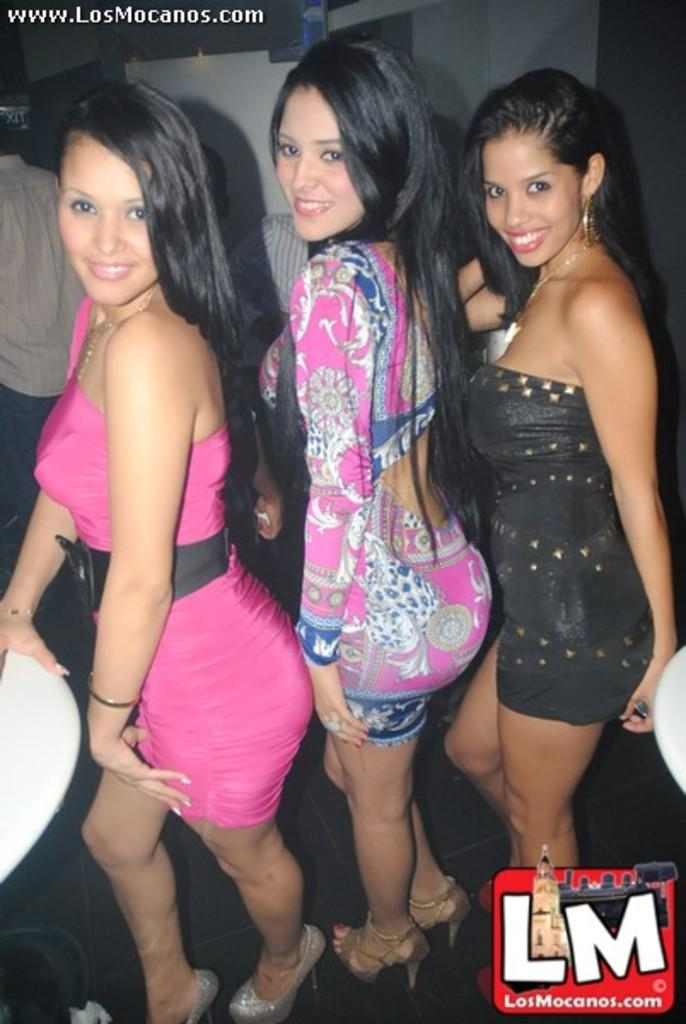How many women are in the image? There are three women in the image. What are the women doing in the image? The women are standing and smiling. Can you describe the people in the background of the image? There are people in the background of the image, but their specific actions or appearances are not mentioned in the provided facts. What type of prison can be seen in the image? There is no prison present in the image; it features three women who are standing and smiling. How does the motion of the women affect the overall composition of the image? The provided facts do not mention any motion of the women, only that they are standing. 